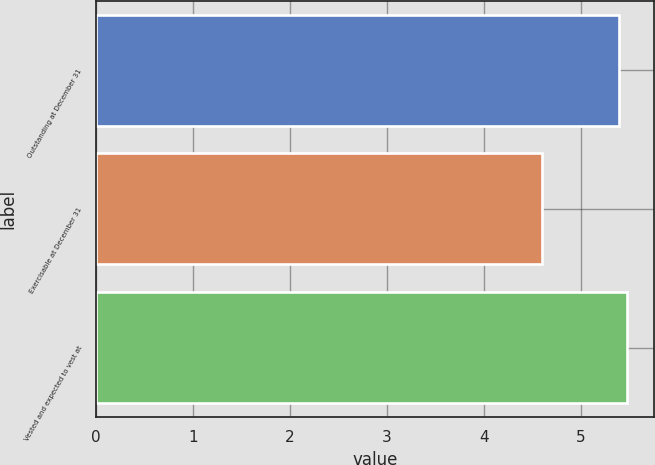<chart> <loc_0><loc_0><loc_500><loc_500><bar_chart><fcel>Outstanding at December 31<fcel>Exercisable at December 31<fcel>Vested and expected to vest at<nl><fcel>5.4<fcel>4.6<fcel>5.48<nl></chart> 